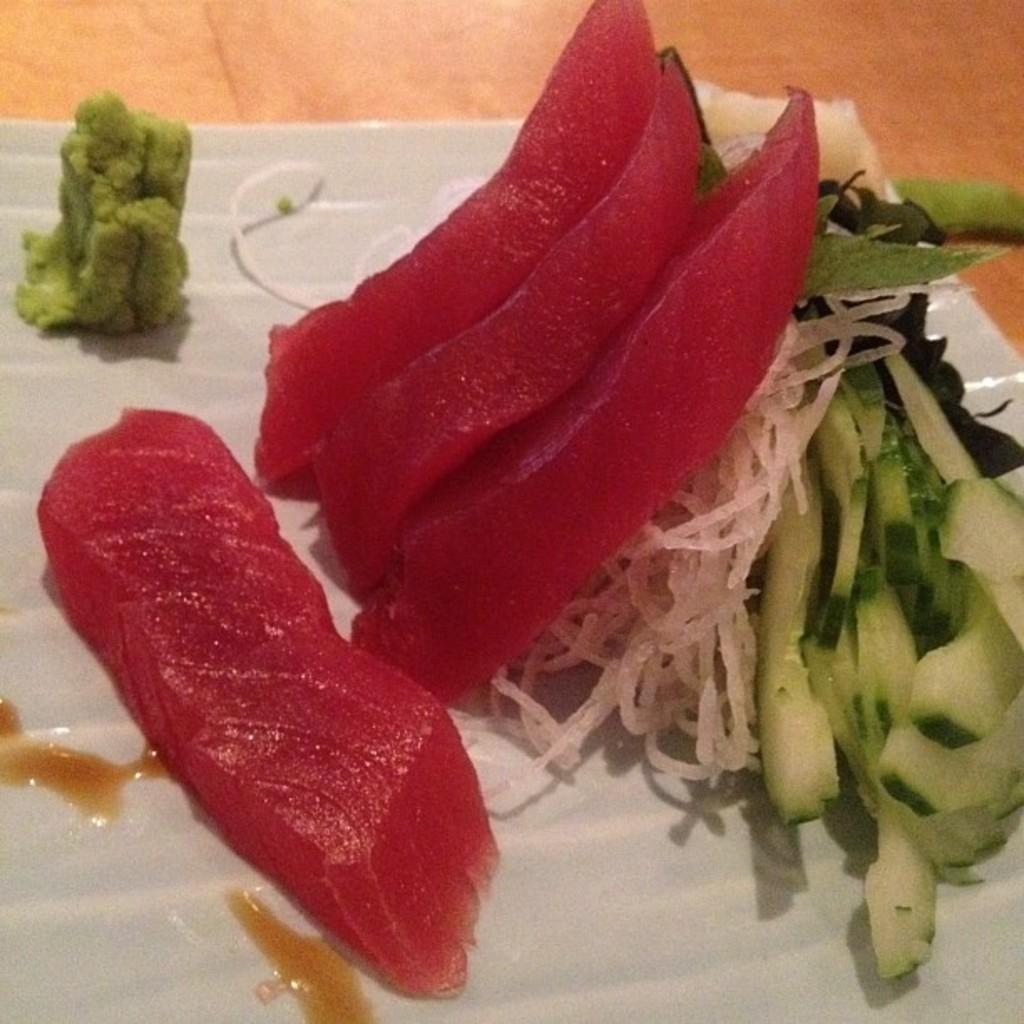What is the color of the surface in the image? The surface in the image is brown colored. What is placed on the surface? There is a white colored plate on the surface. What can be found on the plate? There are food items on the plate. What colors are the food items? The food items have colors: red, green, cream, and white. What type of cough is the person experiencing while eating the food in the image? There is no person present in the image, and therefore no indication of anyone experiencing a cough while eating the food. 